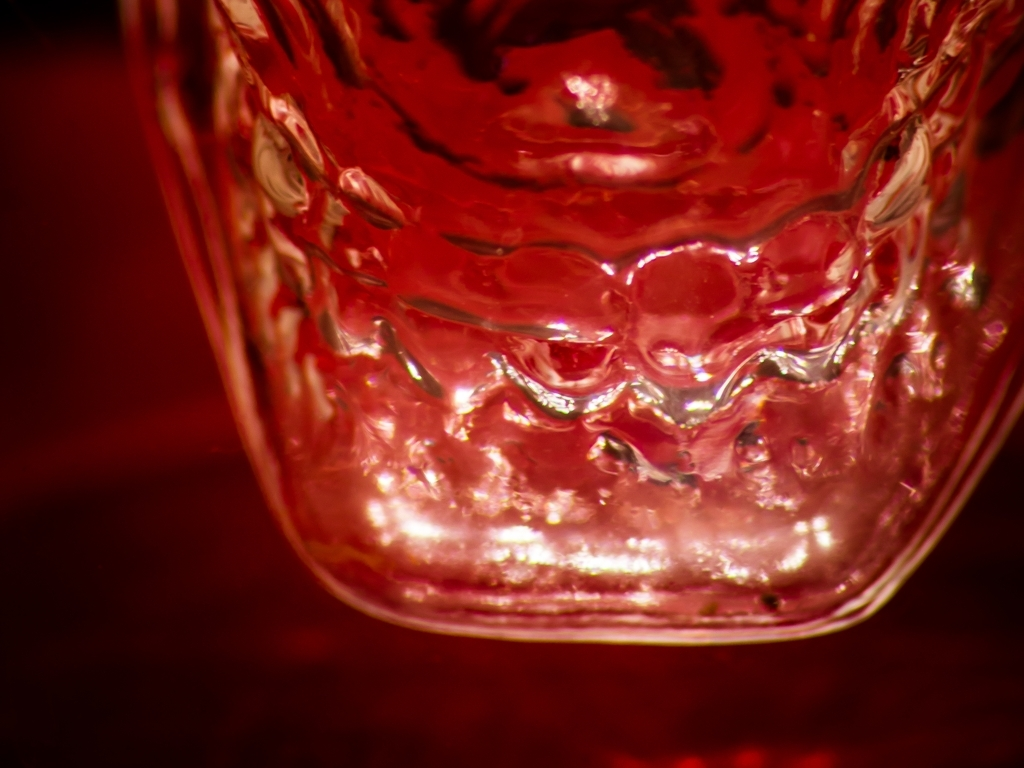Can you tell me about the material of the object in the image? Certainly! The translucent appearance and the way light refracts through the object suggest it is made of glass, featuring a textured surface that catches the light in an interesting pattern. 